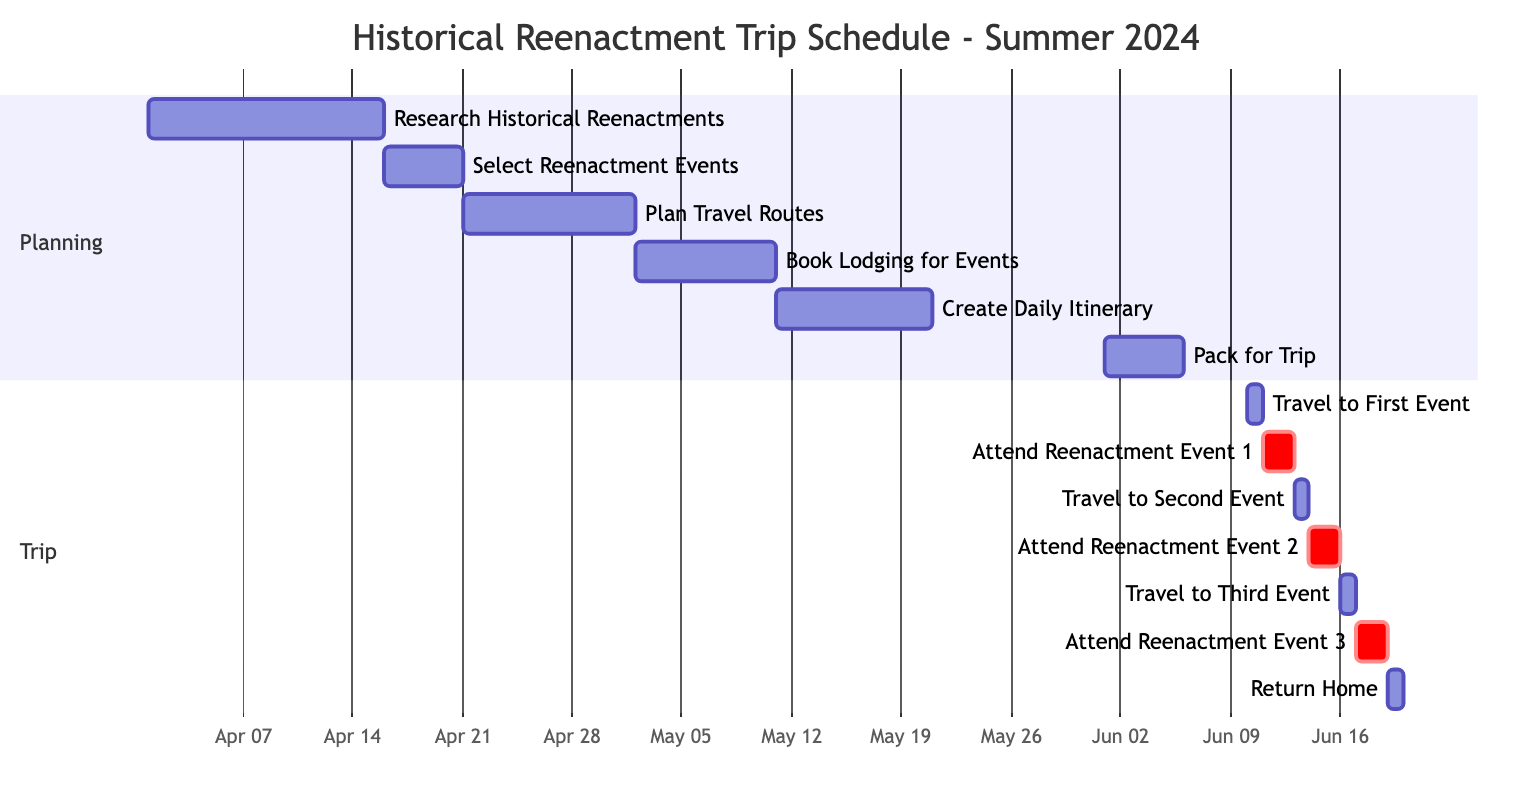What is the duration of the "Research Historical Reenactments" task? The task "Research Historical Reenactments" starts on April 1, 2024, and ends on April 15, 2024. To find the duration, we count the total number of days from the start date to the end date, which is 15 days.
Answer: 15 days What starts immediately after "Select Reenactment Events"? The task "Plan Travel Routes" begins right after "Select Reenactment Events" ends on April 20, 2024. The next task starts on April 21, 2024, indicating a direct continuation in the schedule.
Answer: Plan Travel Routes How many days is the total travel time spent attending events? The travel time includes three separate trips: to the first event (1 day), to the second event (1 day), and to the third event (1 day). This adds up to a total of 3 days of travel time.
Answer: 3 days What overlapping tasks occur before the trip starts? Overlapping tasks before the trip start include "Pack for Trip" (June 1-5) which ends just before "Travel to First Event" (June 10) begins. Additionally, "Create Daily Itinerary" (May 11-20) is a task that can be seen as providing ongoing preparations leading up to the trip start.
Answer: Pack for Trip, Create Daily Itinerary How many events are attended during the trip? There are three distinct reenactment events in the trip: "Attend Reenactment Event 1," "Attend Reenactment Event 2," and "Attend Reenactment Event 3." Counting each event gives a total of three events attended.
Answer: 3 events What is the last task in the diagram? The last task in the diagram is "Return Home," which is scheduled for June 19, 2024. It signifies the completion of the trip.
Answer: Return Home Which task has the longest duration? The task "Research Historical Reenactments" spans from April 1 to April 15, totaling 15 days, which is the longest duration compared to the other tasks listed in the schedule.
Answer: Research Historical Reenactments On which day does the first reenactment event occur? The first reenactment event occurs on June 11, 2024. This is the starting date for "Attend Reenactment Event 1."
Answer: June 11 What task occurs on the same day as "Travel to Second Event"? The task "Travel to Second Event" occurs on June 13, 2024. There is no other task listed on that day, indicating it stands alone.
Answer: None 